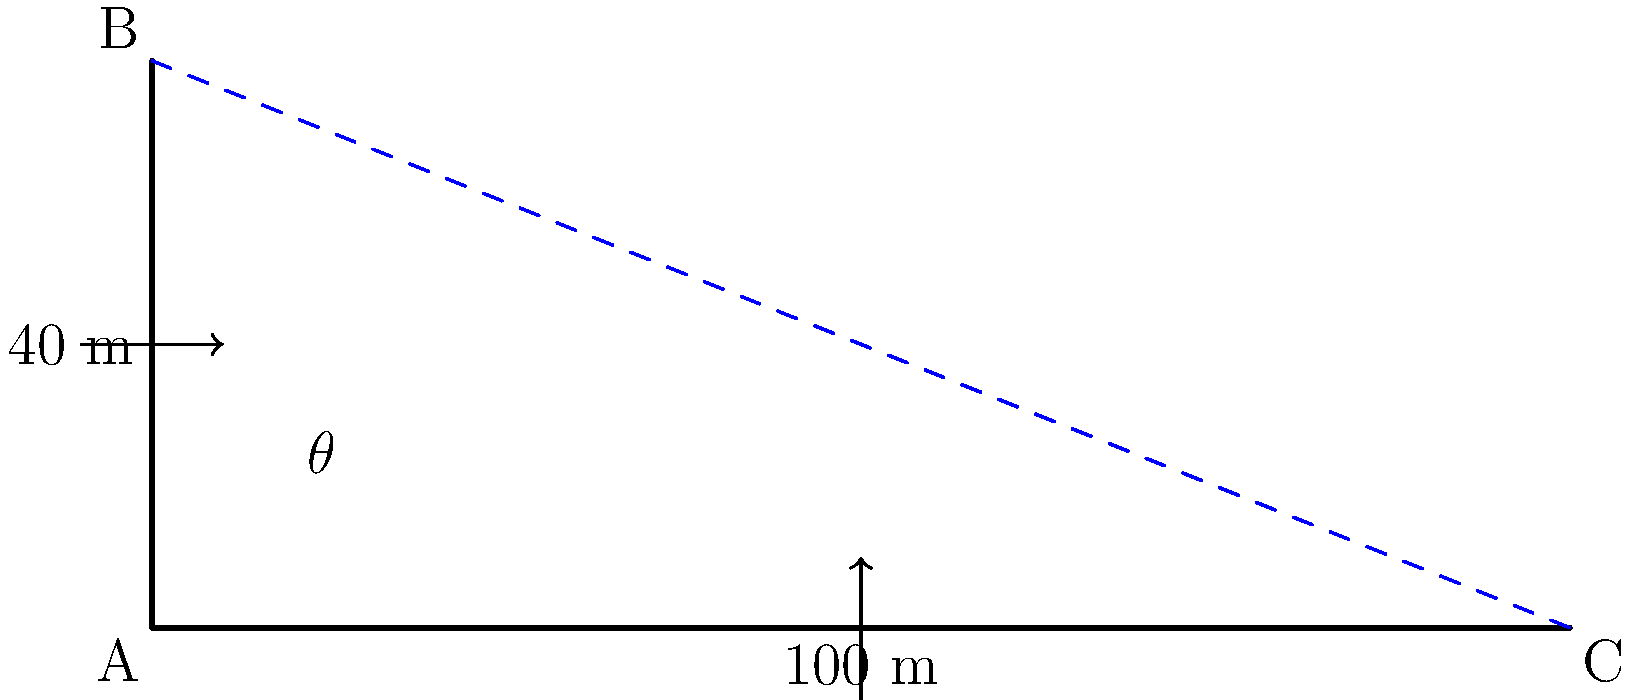As a tour guide at a scenic overlook in Luxembourg, you want to calculate the viewing angle for your visitors. The overlook is situated on a cliff 40 meters high, and you can see a point on the ground 100 meters away from the base of the cliff. What is the viewing angle $\theta$ in degrees? To solve this problem, we'll use trigonometry:

1. Identify the triangle: We have a right-angled triangle with the following sides:
   - Adjacent side (ground distance) = 100 m
   - Opposite side (cliff height) = 40 m
   - Hypotenuse (line of sight)

2. Choose the appropriate trigonometric function:
   We want to find the angle, and we know the opposite and adjacent sides. This calls for the tangent function.

3. Set up the equation:
   $$\tan(\theta) = \frac{\text{opposite}}{\text{adjacent}} = \frac{40}{100} = 0.4$$

4. Solve for $\theta$:
   $$\theta = \arctan(0.4)$$

5. Calculate the result:
   $$\theta \approx 21.80^\circ$$

6. Round to two decimal places:
   $$\theta \approx 21.80^\circ$$
Answer: $21.80^\circ$ 